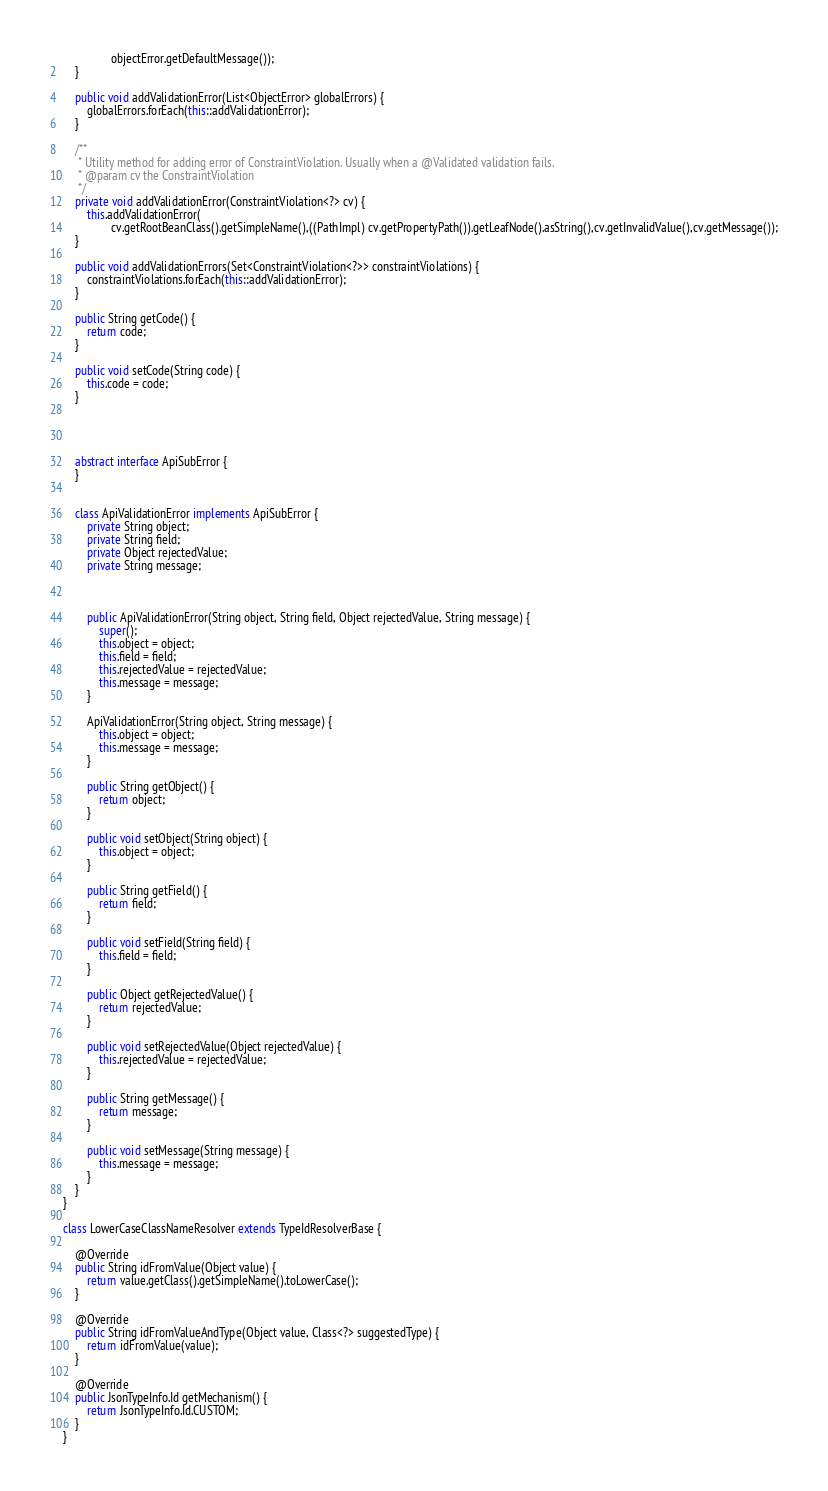<code> <loc_0><loc_0><loc_500><loc_500><_Java_>                objectError.getDefaultMessage());
    }

    public void addValidationError(List<ObjectError> globalErrors) {
        globalErrors.forEach(this::addValidationError);
    }

    /**
     * Utility method for adding error of ConstraintViolation. Usually when a @Validated validation fails.
     * @param cv the ConstraintViolation
     */
    private void addValidationError(ConstraintViolation<?> cv) {
        this.addValidationError(
                cv.getRootBeanClass().getSimpleName(),((PathImpl) cv.getPropertyPath()).getLeafNode().asString(),cv.getInvalidValue(),cv.getMessage());
    }

    public void addValidationErrors(Set<ConstraintViolation<?>> constraintViolations) {
        constraintViolations.forEach(this::addValidationError);
    }

    public String getCode() {
		return code;
	}

	public void setCode(String code) {
		this.code = code;
	}




	abstract interface ApiSubError {
    }

  
    class ApiValidationError implements ApiSubError {
        private String object;
        private String field;
        private Object rejectedValue;
        private String message;

        
        
        public ApiValidationError(String object, String field, Object rejectedValue, String message) {
			super();
			this.object = object;
			this.field = field;
			this.rejectedValue = rejectedValue;
			this.message = message;
		}

		ApiValidationError(String object, String message) {
            this.object = object;
            this.message = message;
        }

		public String getObject() {
			return object;
		}

		public void setObject(String object) {
			this.object = object;
		}

		public String getField() {
			return field;
		}

		public void setField(String field) {
			this.field = field;
		}

		public Object getRejectedValue() {
			return rejectedValue;
		}

		public void setRejectedValue(Object rejectedValue) {
			this.rejectedValue = rejectedValue;
		}

		public String getMessage() {
			return message;
		}

		public void setMessage(String message) {
			this.message = message;
		}
    }
}

class LowerCaseClassNameResolver extends TypeIdResolverBase {

    @Override
    public String idFromValue(Object value) {
        return value.getClass().getSimpleName().toLowerCase();
    }

    @Override
    public String idFromValueAndType(Object value, Class<?> suggestedType) {
        return idFromValue(value);
    }

    @Override
    public JsonTypeInfo.Id getMechanism() {
        return JsonTypeInfo.Id.CUSTOM;
    }
}</code> 